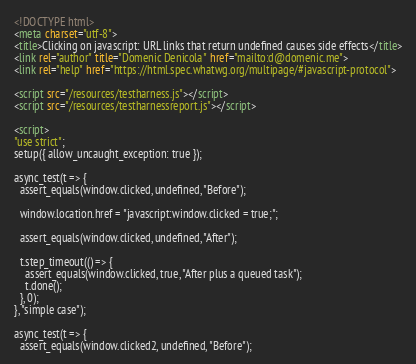Convert code to text. <code><loc_0><loc_0><loc_500><loc_500><_HTML_><!DOCTYPE html>
<meta charset="utf-8">
<title>Clicking on javascript: URL links that return undefined causes side effects</title>
<link rel="author" title="Domenic Denicola" href="mailto:d@domenic.me">
<link rel="help" href="https://html.spec.whatwg.org/multipage/#javascript-protocol">

<script src="/resources/testharness.js"></script>
<script src="/resources/testharnessreport.js"></script>

<script>
"use strict";
setup({ allow_uncaught_exception: true });

async_test(t => {
  assert_equals(window.clicked, undefined, "Before");

  window.location.href = "javascript:window.clicked = true;";

  assert_equals(window.clicked, undefined, "After");

  t.step_timeout(() => {
    assert_equals(window.clicked, true, "After plus a queued task");
    t.done();
  }, 0);
}, "simple case");

async_test(t => {
  assert_equals(window.clicked2, undefined, "Before");
</code> 